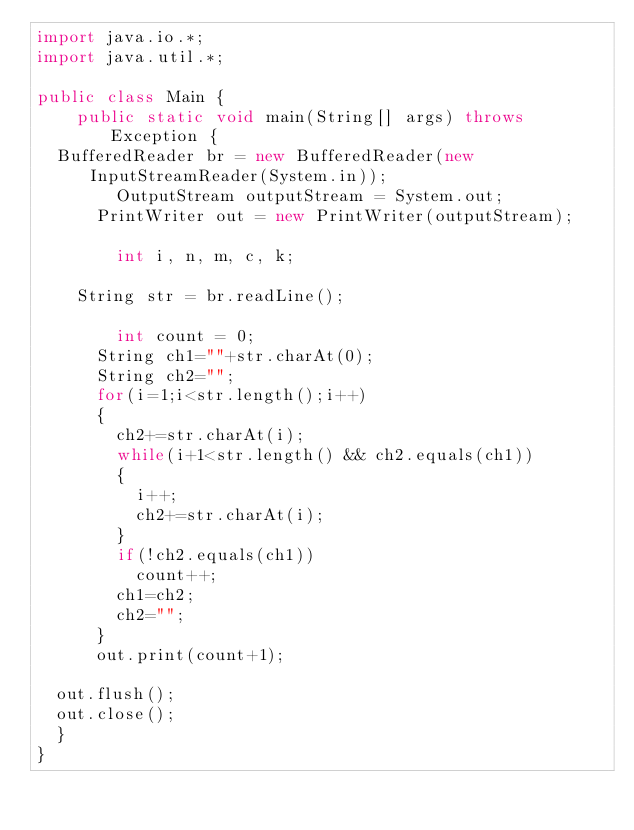Convert code to text. <code><loc_0><loc_0><loc_500><loc_500><_Java_>import java.io.*;
import java.util.*;

public class Main {
    public static void main(String[] args) throws Exception {
	BufferedReader br = new BufferedReader(new InputStreamReader(System.in));
        OutputStream outputStream = System.out;
    	PrintWriter out = new PrintWriter(outputStream);

        int i, n, m, c, k;

		String str = br.readLine();    
        
      	int count = 0;
      String ch1=""+str.charAt(0);
      String ch2="";
      for(i=1;i<str.length();i++)
      {
        ch2+=str.charAt(i);
        while(i+1<str.length() && ch2.equals(ch1))
        {
          i++;
          ch2+=str.charAt(i);
        }
        if(!ch2.equals(ch1))
        	count++;
        ch1=ch2;
        ch2="";
      }
      out.print(count+1);
	
	out.flush();
	out.close();
	}
}</code> 